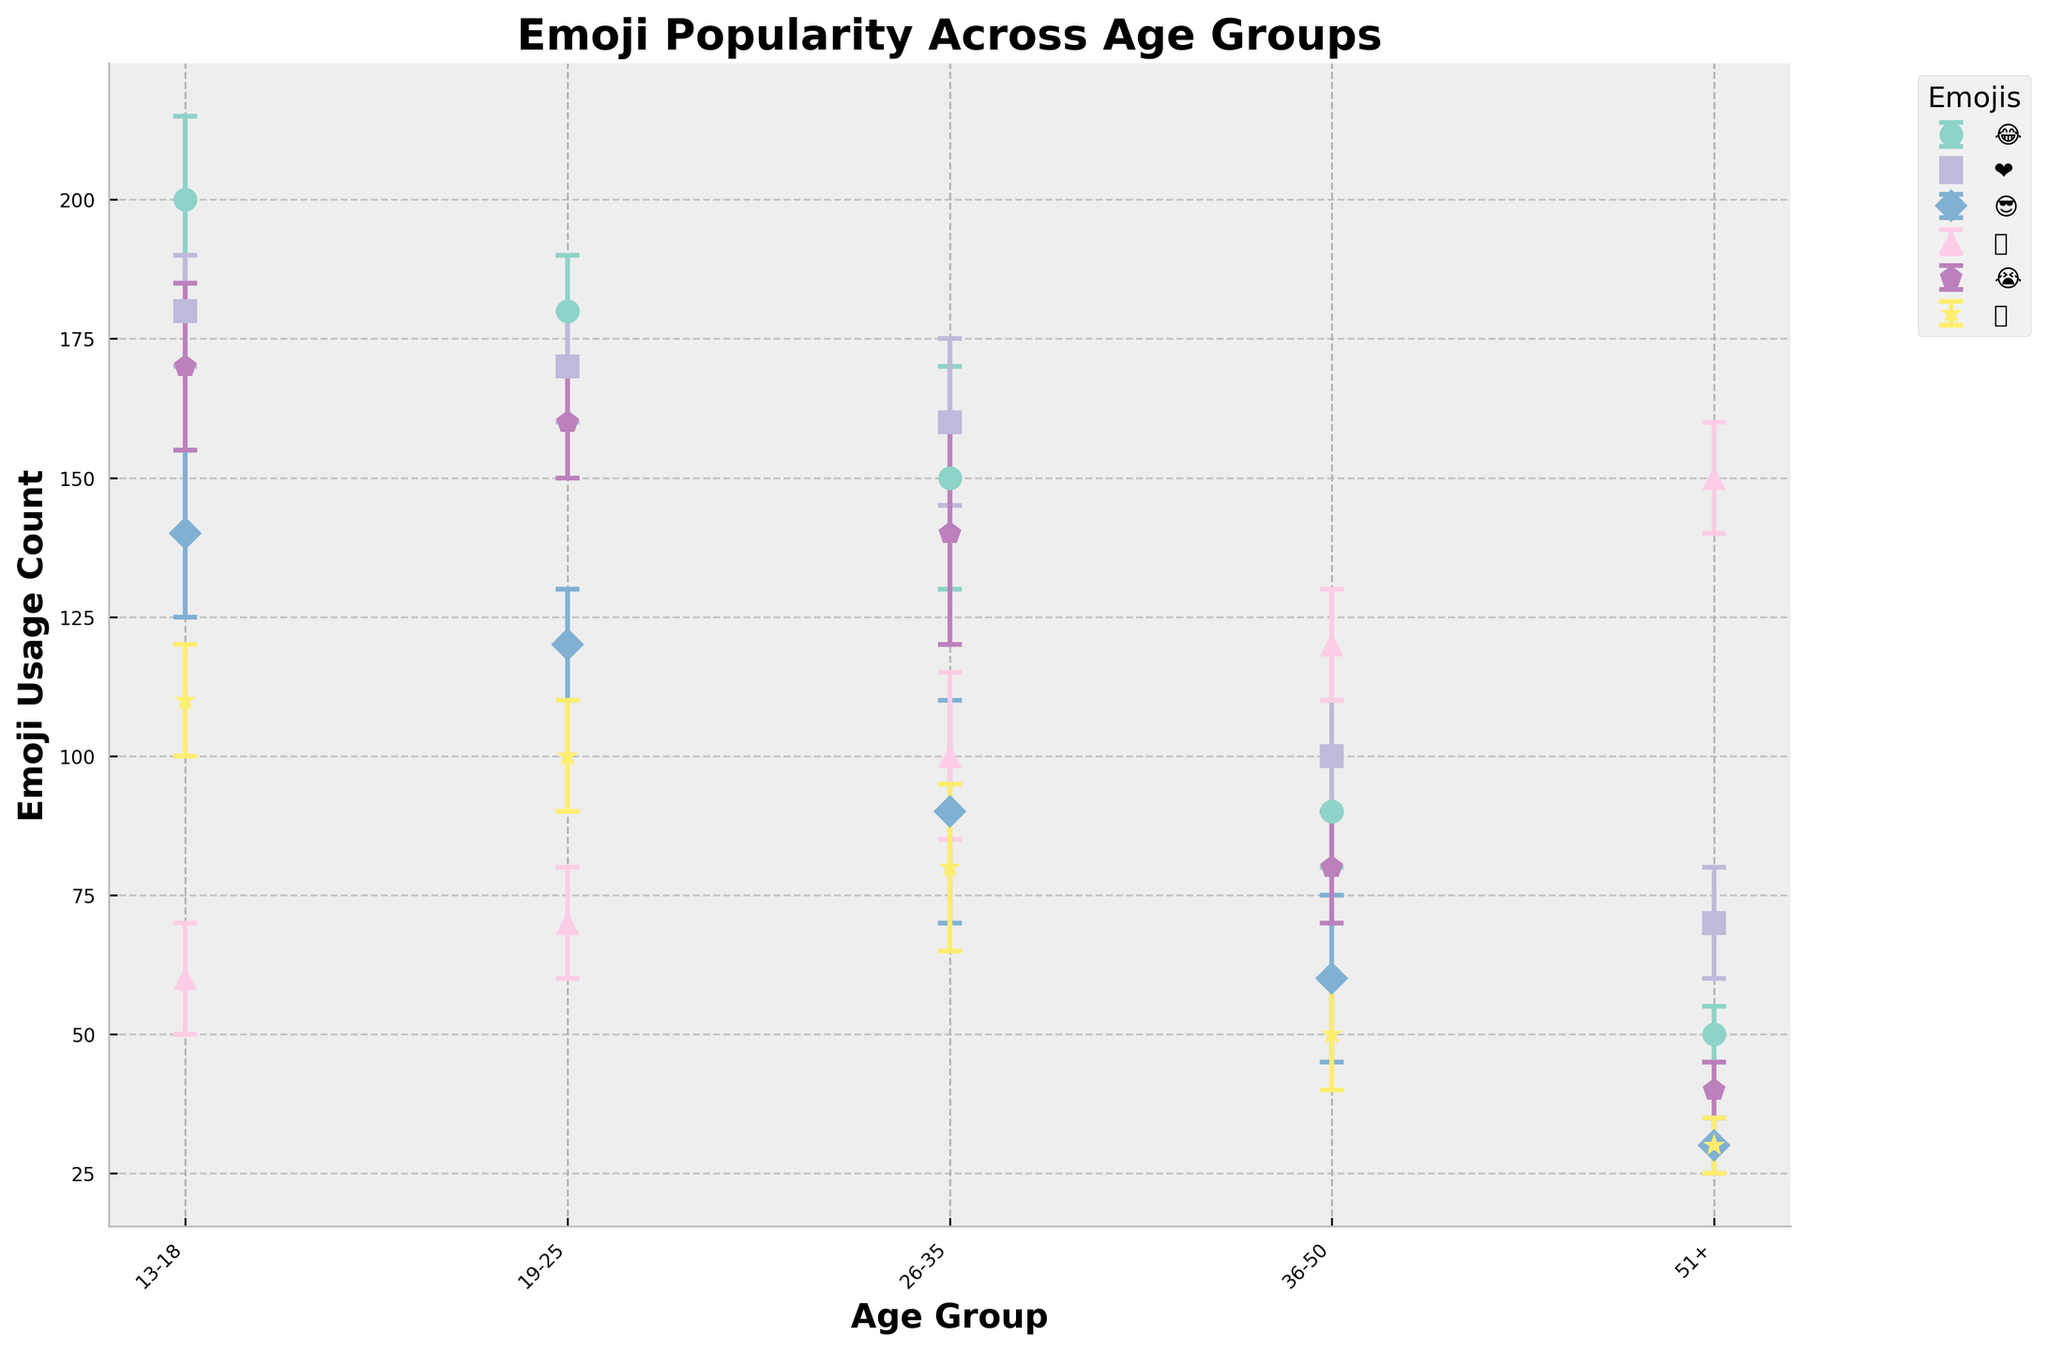What is the title of the figure? The title is usually displayed at the top of the figure. Here, it reads “Emoji Popularity Across Age Groups”.
Answer: Emoji Popularity Across Age Groups Which emoji has the highest use count in the age group 13-18? Look for the emoji with the highest point in the section labeled 13-18. The emoji 😂 has the highest count at 200.
Answer: 😂 How does the use of the emoji ❤️ change with age? Check the data points for ❤️ across different age groups. It starts at 180 for 13-18 years and decreases to 70 for 51+ years.
Answer: It decreases What is the use count of the 🙏 emoji for the age group 51+? Locate the data point for the 🙏 emoji under the 51+ category, which corresponds with a height of 150 on the y-axis.
Answer: 150 Which emojis show an increase in usage with age? Compare data points across age groups. The 🙏 emoji is the only one that increases as age increases.
Answer: 🙏 What is the difference in use count of the emoji 😂 between age groups 13-18 and 51+? Locate the use counts for 😂 in 13-18 (200) and 51+ (50). Subtract the smaller from the larger: 200-50 = 150.
Answer: 150 Which emoji has the most significant drop in use count from 13-18 to 51+? Compare the drop for each emoji from 13-18 to 51+. The emoji 😂 drops from 200 to 50, the largest difference of 150.
Answer: 😂 What is the average use count of the 🔥 emoji across all age groups? Add the use counts for 🔥 in each age group (110, 100, 80, 50, 30) and divide by the number of groups: (110+100+80+50+30)/5 = 74.
Answer: 74 Which age group has the smallest variation in use counts across all emojis? Compare the error margins for each age group across all emojis. The 51+ age group consistently has smaller error margins, indicating less variation.
Answer: 51+ Which emoji has the smallest error margin in the 19-25 age group? Locate the error margins for each emoji in the 19-25 age group. The emojis 😂 and 😭 have the smallest error margin of 10.
Answer: 😂, 😭 